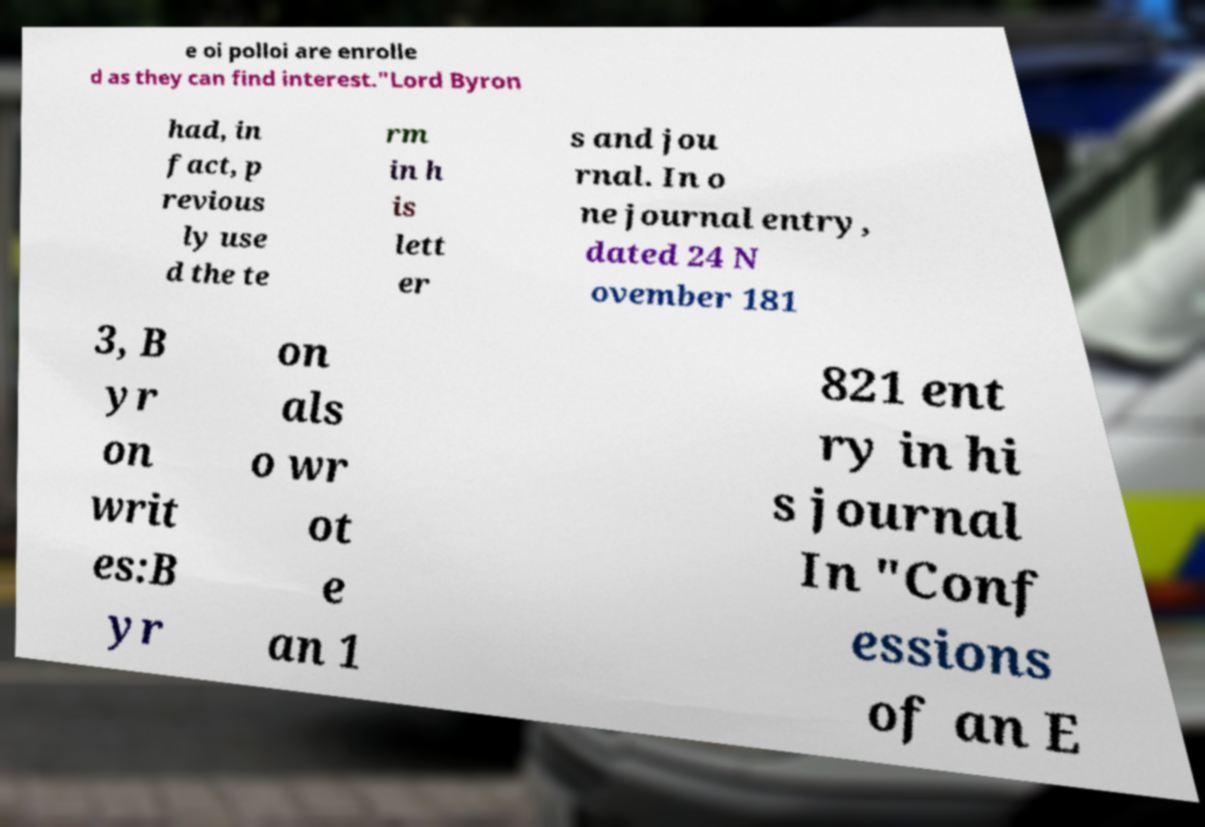There's text embedded in this image that I need extracted. Can you transcribe it verbatim? e oi polloi are enrolle d as they can find interest."Lord Byron had, in fact, p revious ly use d the te rm in h is lett er s and jou rnal. In o ne journal entry, dated 24 N ovember 181 3, B yr on writ es:B yr on als o wr ot e an 1 821 ent ry in hi s journal In "Conf essions of an E 